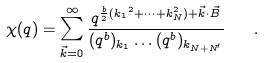<formula> <loc_0><loc_0><loc_500><loc_500>\chi ( q ) = \sum _ { \vec { k } = 0 } ^ { \infty } \frac { q ^ { \frac { b } { 2 } ( { k _ { 1 } } ^ { 2 } + \dots + k _ { N } ^ { 2 } ) + \vec { k } \cdot \vec { B } } } { ( q ^ { b } ) _ { k _ { 1 } } \dots ( q ^ { b } ) _ { k _ { N + N ^ { \prime } } } } \quad .</formula> 